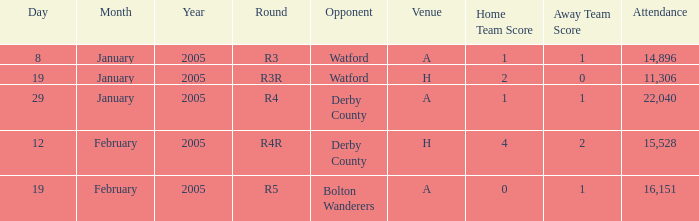On which date does the r3 round take place? 8 January 2005. 